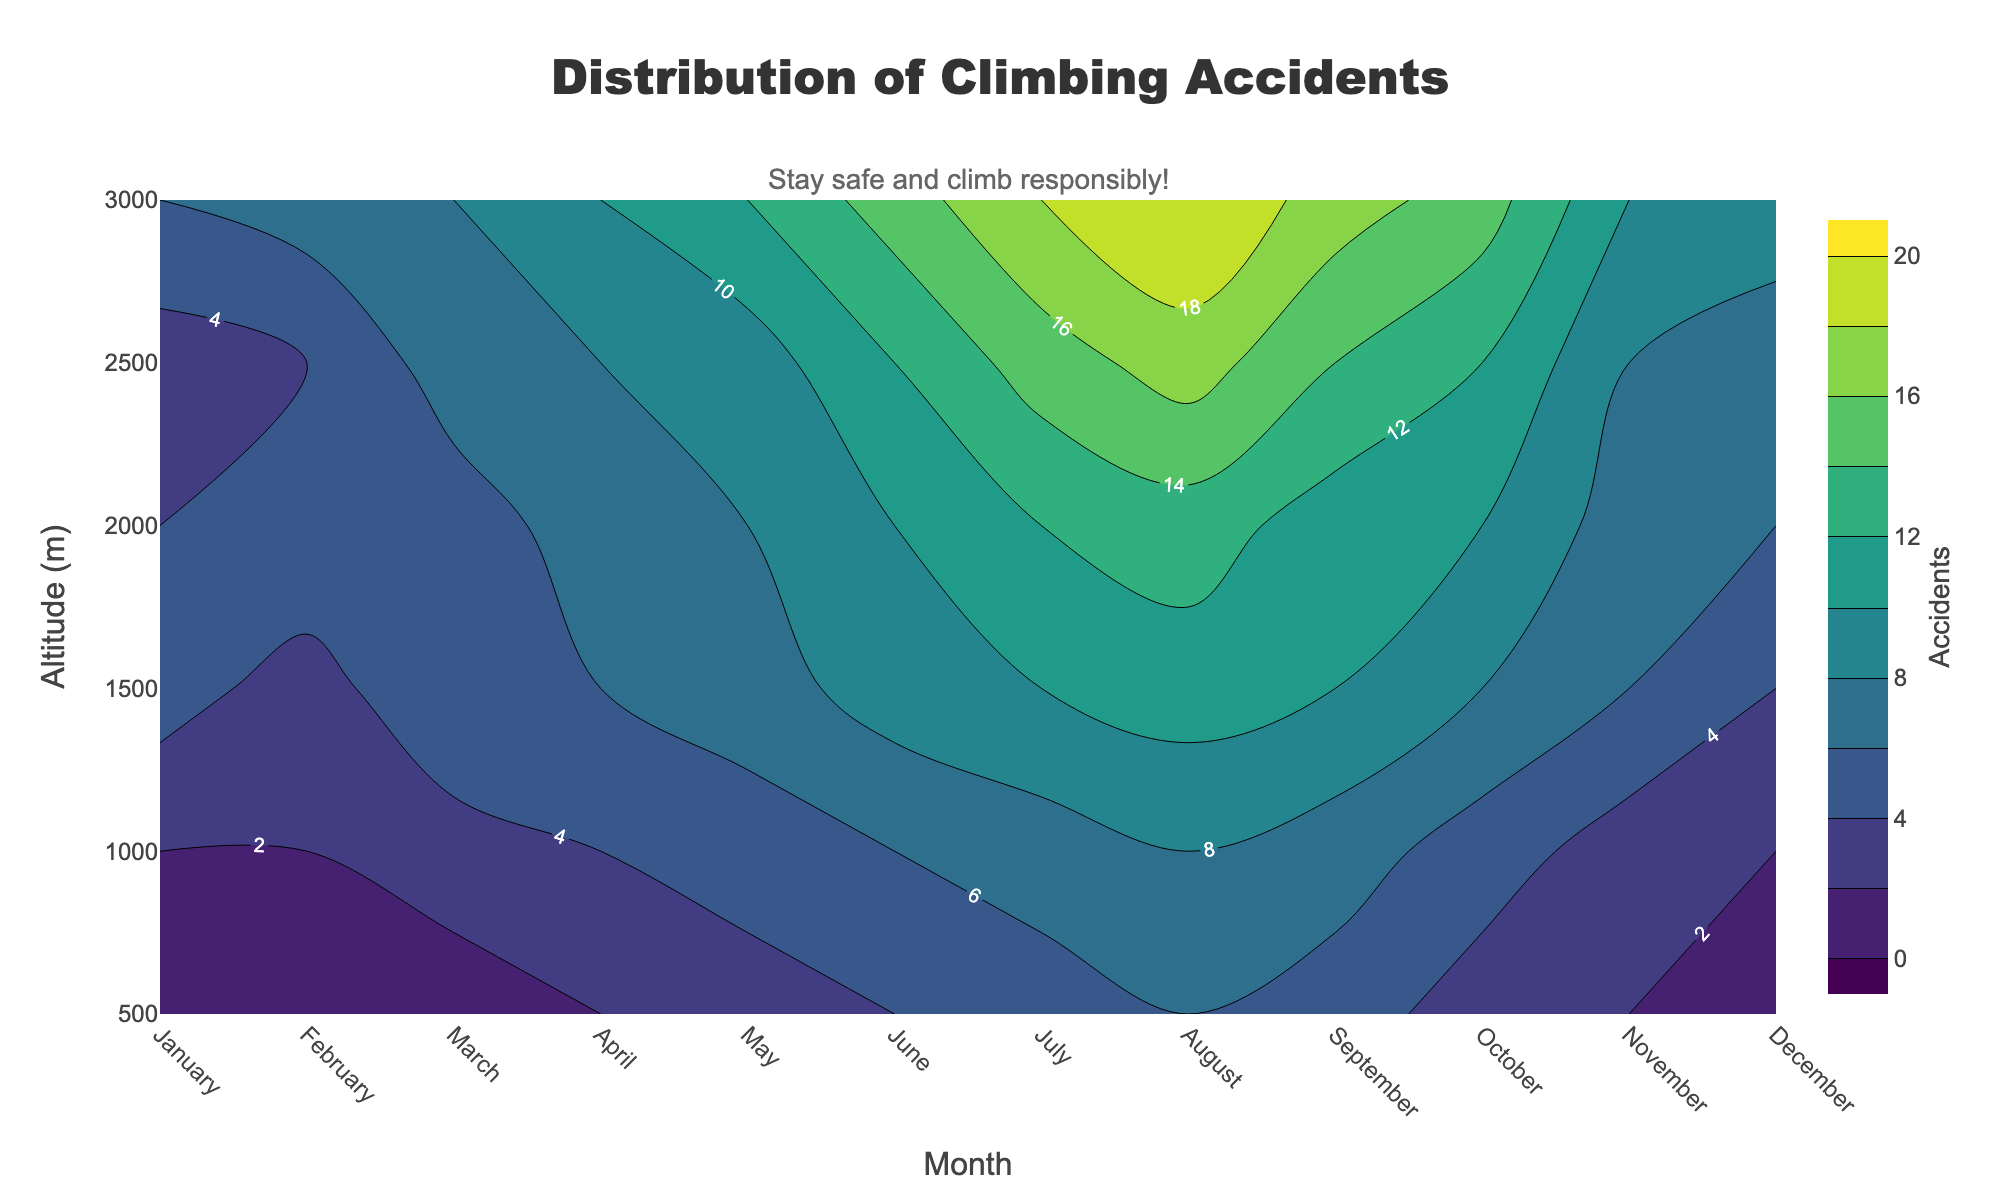What is the title of the figure? The title is displayed at the top of the figure and is clearly labeled.
Answer: Distribution of Climbing Accidents Which month has the highest number of accidents at 3000 meters? Check the y-axis for 3000 meters and observe which month's contour label indicates the highest number of accidents.
Answer: August How does the number of accidents at 1500 meters in April compare to July? Check the y-axis for 1500 meters and compare the contour labels for April and July.
Answer: April has fewer accidents than July What is the altitude range covered by the contour plot? The altitude range can be found by looking at the lowest and highest points on the y-axis.
Answer: 500 to 3000 meters How many accidents occurred at 1000 meters in March? Identify the 1000 meter point on the y-axis for March and read the contour label.
Answer: 3 During which month does the number of accidents at 2000 meters reach its peak? Follow the 2000 meter line on the y-axis and check the month with the highest contour label.
Answer: August What is the general trend in accidents from January to December at 500 meters? Follow the 500 meter line on the y-axis across all months and observe the change in contour labels.
Answer: Increasing Which altitude has the highest number of accidents in December? Locate December on the x-axis and observe the y-axis contour labels for the highest number of accidents.
Answer: 3000 meters How do the number of accidents in May at 2000 meters compare to October at the same altitude? Compare the contour labels for May and October at the 2000 meter altitude.
Answer: May has more accidents than October What can be inferred about climbing safety at higher altitudes during the summer months? Observe the contour density and values for the summer months (June, July, August) at altitudes above 2000 meters.
Answer: Accidents increase significantly 